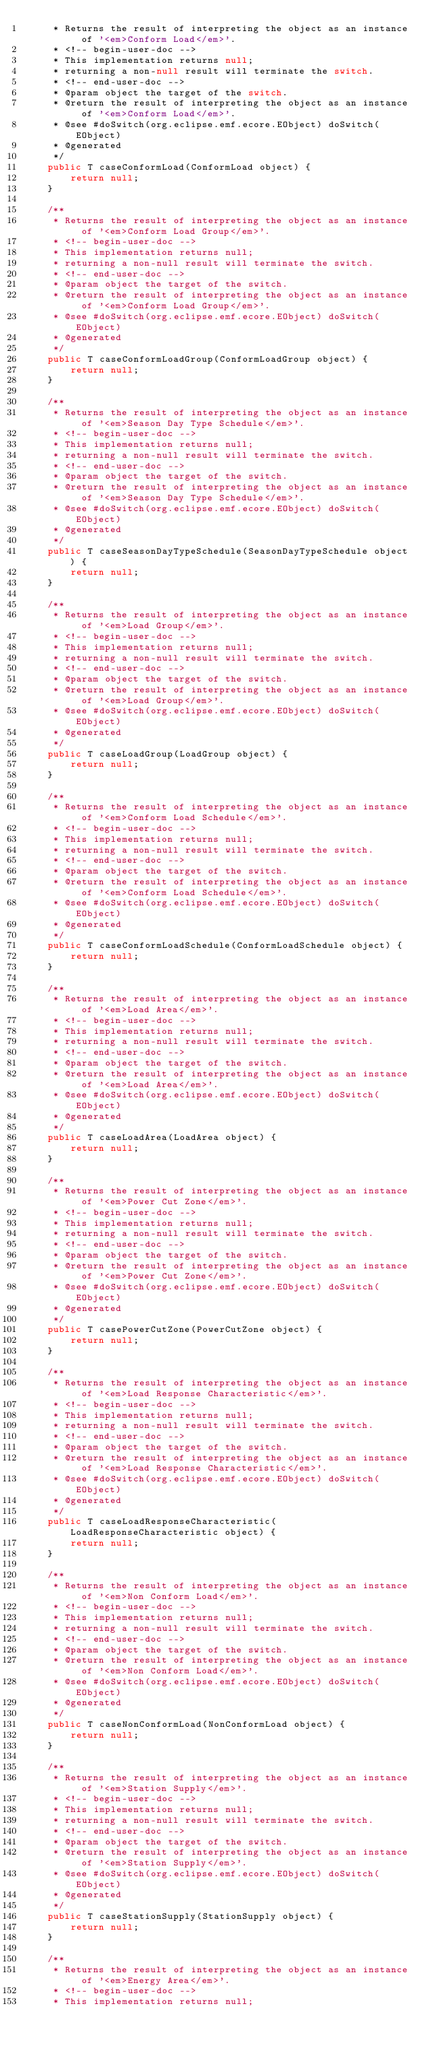Convert code to text. <code><loc_0><loc_0><loc_500><loc_500><_Java_>	 * Returns the result of interpreting the object as an instance of '<em>Conform Load</em>'.
	 * <!-- begin-user-doc -->
	 * This implementation returns null;
	 * returning a non-null result will terminate the switch.
	 * <!-- end-user-doc -->
	 * @param object the target of the switch.
	 * @return the result of interpreting the object as an instance of '<em>Conform Load</em>'.
	 * @see #doSwitch(org.eclipse.emf.ecore.EObject) doSwitch(EObject)
	 * @generated
	 */
	public T caseConformLoad(ConformLoad object) {
		return null;
	}

	/**
	 * Returns the result of interpreting the object as an instance of '<em>Conform Load Group</em>'.
	 * <!-- begin-user-doc -->
	 * This implementation returns null;
	 * returning a non-null result will terminate the switch.
	 * <!-- end-user-doc -->
	 * @param object the target of the switch.
	 * @return the result of interpreting the object as an instance of '<em>Conform Load Group</em>'.
	 * @see #doSwitch(org.eclipse.emf.ecore.EObject) doSwitch(EObject)
	 * @generated
	 */
	public T caseConformLoadGroup(ConformLoadGroup object) {
		return null;
	}

	/**
	 * Returns the result of interpreting the object as an instance of '<em>Season Day Type Schedule</em>'.
	 * <!-- begin-user-doc -->
	 * This implementation returns null;
	 * returning a non-null result will terminate the switch.
	 * <!-- end-user-doc -->
	 * @param object the target of the switch.
	 * @return the result of interpreting the object as an instance of '<em>Season Day Type Schedule</em>'.
	 * @see #doSwitch(org.eclipse.emf.ecore.EObject) doSwitch(EObject)
	 * @generated
	 */
	public T caseSeasonDayTypeSchedule(SeasonDayTypeSchedule object) {
		return null;
	}

	/**
	 * Returns the result of interpreting the object as an instance of '<em>Load Group</em>'.
	 * <!-- begin-user-doc -->
	 * This implementation returns null;
	 * returning a non-null result will terminate the switch.
	 * <!-- end-user-doc -->
	 * @param object the target of the switch.
	 * @return the result of interpreting the object as an instance of '<em>Load Group</em>'.
	 * @see #doSwitch(org.eclipse.emf.ecore.EObject) doSwitch(EObject)
	 * @generated
	 */
	public T caseLoadGroup(LoadGroup object) {
		return null;
	}

	/**
	 * Returns the result of interpreting the object as an instance of '<em>Conform Load Schedule</em>'.
	 * <!-- begin-user-doc -->
	 * This implementation returns null;
	 * returning a non-null result will terminate the switch.
	 * <!-- end-user-doc -->
	 * @param object the target of the switch.
	 * @return the result of interpreting the object as an instance of '<em>Conform Load Schedule</em>'.
	 * @see #doSwitch(org.eclipse.emf.ecore.EObject) doSwitch(EObject)
	 * @generated
	 */
	public T caseConformLoadSchedule(ConformLoadSchedule object) {
		return null;
	}

	/**
	 * Returns the result of interpreting the object as an instance of '<em>Load Area</em>'.
	 * <!-- begin-user-doc -->
	 * This implementation returns null;
	 * returning a non-null result will terminate the switch.
	 * <!-- end-user-doc -->
	 * @param object the target of the switch.
	 * @return the result of interpreting the object as an instance of '<em>Load Area</em>'.
	 * @see #doSwitch(org.eclipse.emf.ecore.EObject) doSwitch(EObject)
	 * @generated
	 */
	public T caseLoadArea(LoadArea object) {
		return null;
	}

	/**
	 * Returns the result of interpreting the object as an instance of '<em>Power Cut Zone</em>'.
	 * <!-- begin-user-doc -->
	 * This implementation returns null;
	 * returning a non-null result will terminate the switch.
	 * <!-- end-user-doc -->
	 * @param object the target of the switch.
	 * @return the result of interpreting the object as an instance of '<em>Power Cut Zone</em>'.
	 * @see #doSwitch(org.eclipse.emf.ecore.EObject) doSwitch(EObject)
	 * @generated
	 */
	public T casePowerCutZone(PowerCutZone object) {
		return null;
	}

	/**
	 * Returns the result of interpreting the object as an instance of '<em>Load Response Characteristic</em>'.
	 * <!-- begin-user-doc -->
	 * This implementation returns null;
	 * returning a non-null result will terminate the switch.
	 * <!-- end-user-doc -->
	 * @param object the target of the switch.
	 * @return the result of interpreting the object as an instance of '<em>Load Response Characteristic</em>'.
	 * @see #doSwitch(org.eclipse.emf.ecore.EObject) doSwitch(EObject)
	 * @generated
	 */
	public T caseLoadResponseCharacteristic(LoadResponseCharacteristic object) {
		return null;
	}

	/**
	 * Returns the result of interpreting the object as an instance of '<em>Non Conform Load</em>'.
	 * <!-- begin-user-doc -->
	 * This implementation returns null;
	 * returning a non-null result will terminate the switch.
	 * <!-- end-user-doc -->
	 * @param object the target of the switch.
	 * @return the result of interpreting the object as an instance of '<em>Non Conform Load</em>'.
	 * @see #doSwitch(org.eclipse.emf.ecore.EObject) doSwitch(EObject)
	 * @generated
	 */
	public T caseNonConformLoad(NonConformLoad object) {
		return null;
	}

	/**
	 * Returns the result of interpreting the object as an instance of '<em>Station Supply</em>'.
	 * <!-- begin-user-doc -->
	 * This implementation returns null;
	 * returning a non-null result will terminate the switch.
	 * <!-- end-user-doc -->
	 * @param object the target of the switch.
	 * @return the result of interpreting the object as an instance of '<em>Station Supply</em>'.
	 * @see #doSwitch(org.eclipse.emf.ecore.EObject) doSwitch(EObject)
	 * @generated
	 */
	public T caseStationSupply(StationSupply object) {
		return null;
	}

	/**
	 * Returns the result of interpreting the object as an instance of '<em>Energy Area</em>'.
	 * <!-- begin-user-doc -->
	 * This implementation returns null;</code> 